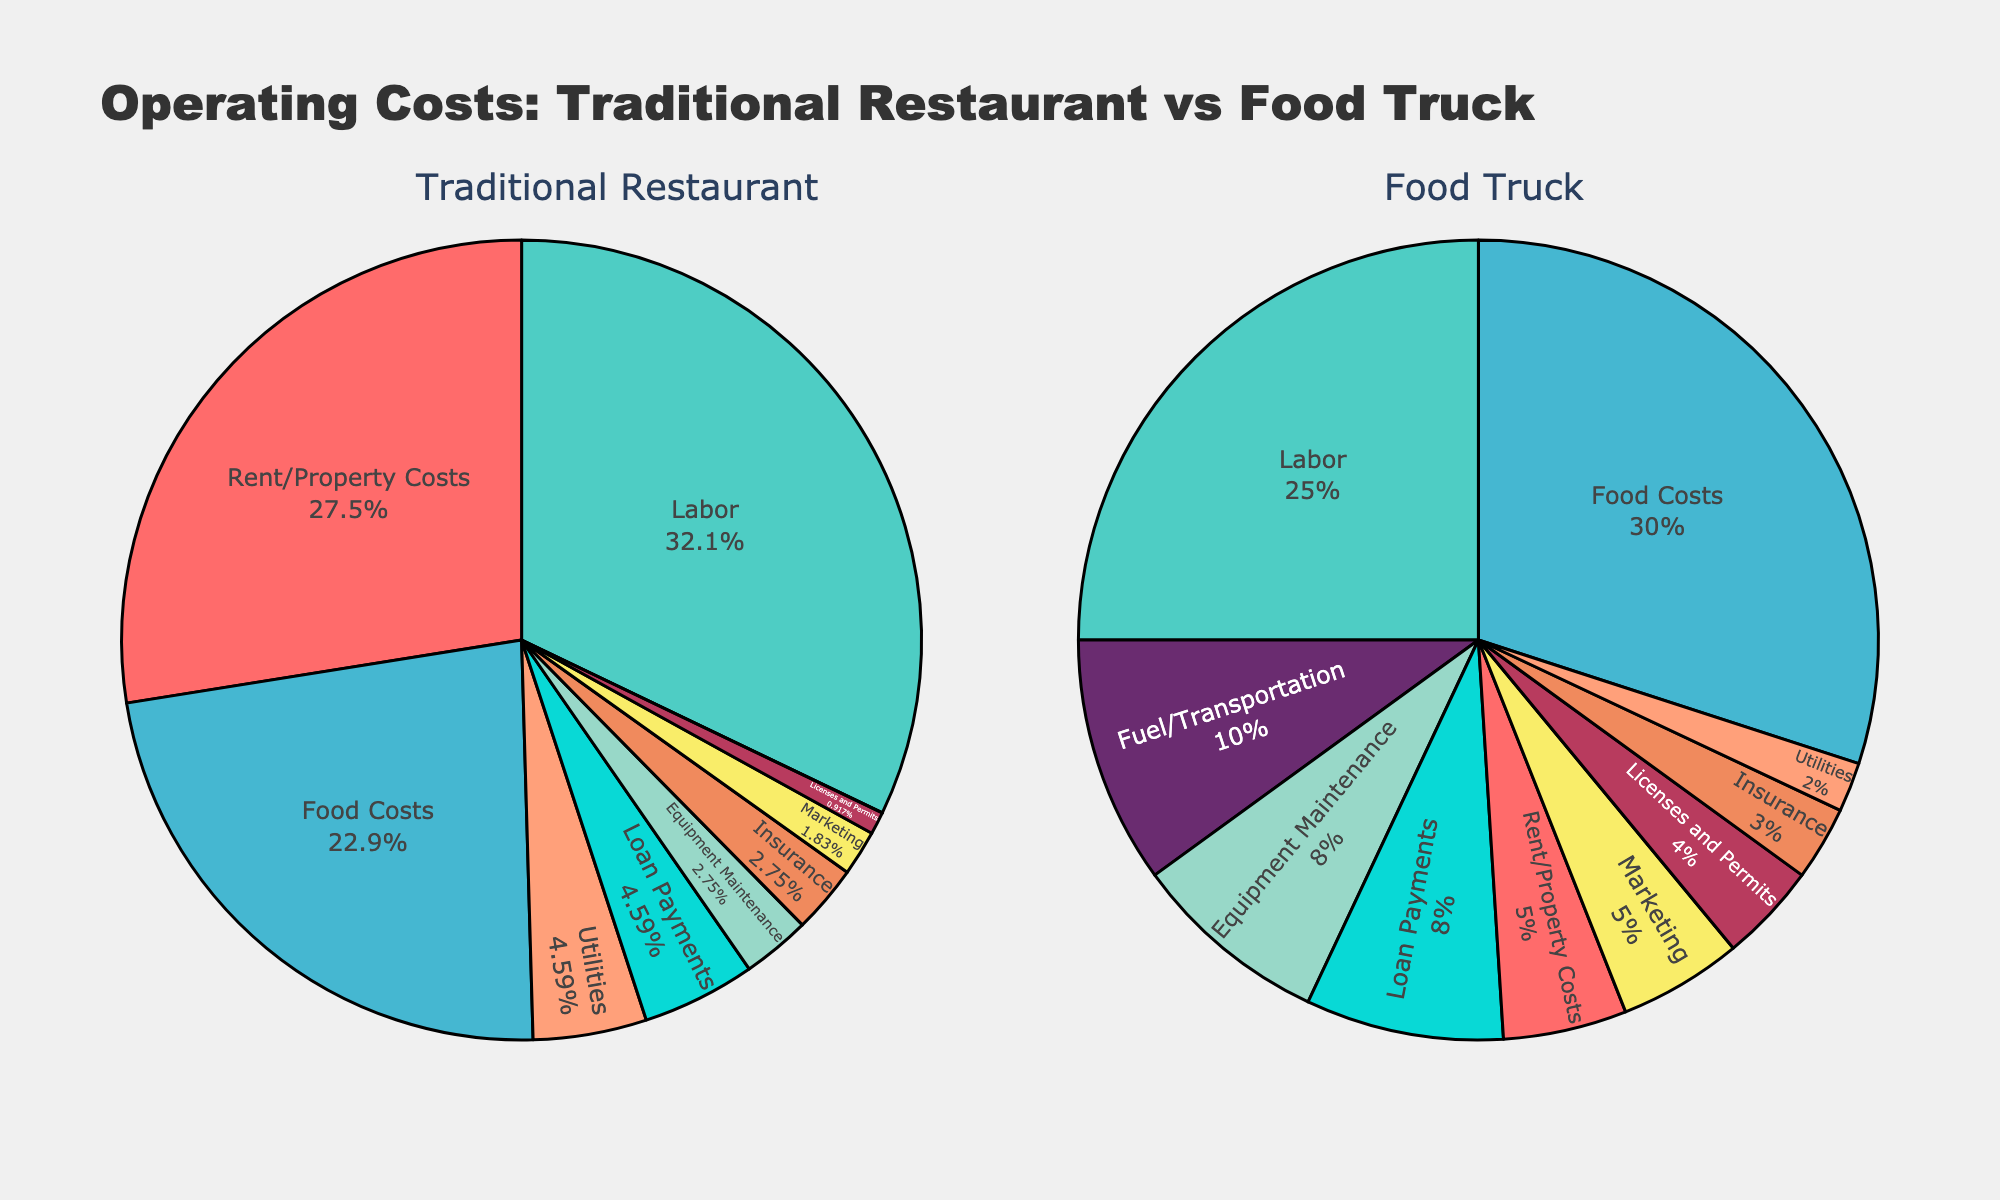Which category has the highest operating cost for traditional restaurants? The pie chart for traditional restaurants shows that the largest section is labeled as "Labor," indicating it constitutes the highest operating cost.
Answer: Labor What is the combined percentage of Rent/Property Costs and Labor for traditional restaurants? The pie chart for traditional restaurants shows Rent/Property Costs is 30% and Labor is 35%. Their combined percentage is 30% + 35% = 65%.
Answer: 65% How does the percentage of Food Costs compare between traditional restaurants and food trucks? The traditional restaurants have 25% allocated for Food Costs, while food trucks have 30%. This shows that food trucks spend a higher percentage on Food Costs compared to traditional restaurants.
Answer: Food trucks spend 5% more What is the total percentage of Utilities and Equipment Maintenance for food trucks? The pie chart for food trucks shows Utilities at 2% and Equipment Maintenance at 8%. Adding them gives 2% + 8% = 10%.
Answer: 10% Which type of operating costs (category) is unique to food trucks and not present in traditional restaurants? The pie chart for food trucks includes a section labeled "Fuel/Transportation" which is not present in traditional restaurants.
Answer: Fuel/Transportation In which category do traditional restaurants and food trucks have equal percentages? Both types of charts indicate that the "Insurance" category has the same proportion at 3% for both traditional restaurants and food trucks.
Answer: Insurance By how many percentage points is Marketing cost higher in food trucks compared to traditional restaurants? The pie chart shows Marketing costs are 5% for food trucks and 2% for traditional restaurants. The difference is 5% - 2% = 3%.
Answer: 3% What is the percentage of total operating costs spent on Labor and Food Costs for food trucks? According to the food trucks pie chart, Labor is 25% and Food Costs are 30%. Together they make up 25% + 30% = 55% of total operating costs.
Answer: 55% 